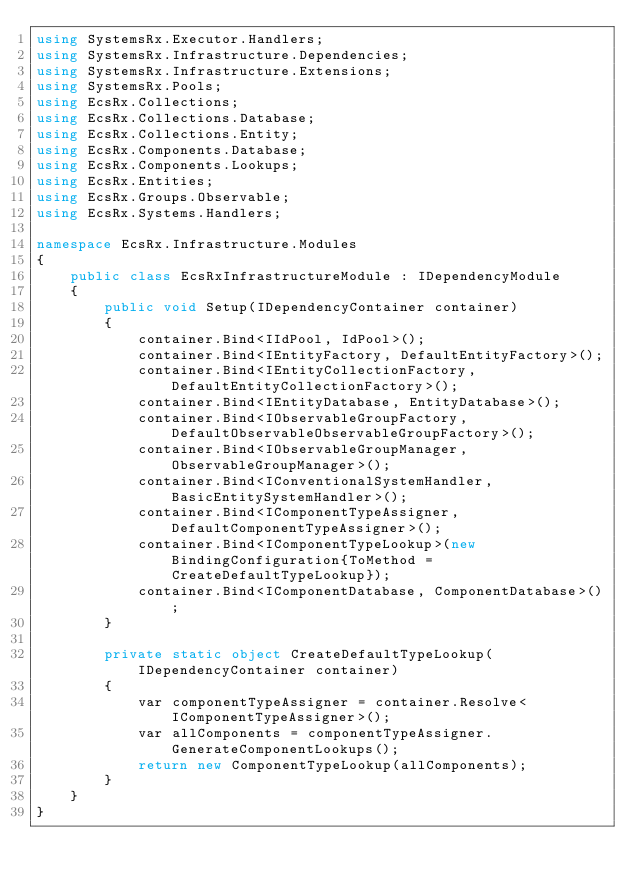Convert code to text. <code><loc_0><loc_0><loc_500><loc_500><_C#_>using SystemsRx.Executor.Handlers;
using SystemsRx.Infrastructure.Dependencies;
using SystemsRx.Infrastructure.Extensions;
using SystemsRx.Pools;
using EcsRx.Collections;
using EcsRx.Collections.Database;
using EcsRx.Collections.Entity;
using EcsRx.Components.Database;
using EcsRx.Components.Lookups;
using EcsRx.Entities;
using EcsRx.Groups.Observable;
using EcsRx.Systems.Handlers;

namespace EcsRx.Infrastructure.Modules
{
    public class EcsRxInfrastructureModule : IDependencyModule
    {
        public void Setup(IDependencyContainer container)
        {
            container.Bind<IIdPool, IdPool>();
            container.Bind<IEntityFactory, DefaultEntityFactory>();
            container.Bind<IEntityCollectionFactory, DefaultEntityCollectionFactory>();
            container.Bind<IEntityDatabase, EntityDatabase>();
            container.Bind<IObservableGroupFactory, DefaultObservableObservableGroupFactory>();
            container.Bind<IObservableGroupManager, ObservableGroupManager>();
            container.Bind<IConventionalSystemHandler, BasicEntitySystemHandler>();
            container.Bind<IComponentTypeAssigner, DefaultComponentTypeAssigner>();
            container.Bind<IComponentTypeLookup>(new BindingConfiguration{ToMethod = CreateDefaultTypeLookup});           
            container.Bind<IComponentDatabase, ComponentDatabase>();
        }

        private static object CreateDefaultTypeLookup(IDependencyContainer container)
        {
            var componentTypeAssigner = container.Resolve<IComponentTypeAssigner>();
            var allComponents = componentTypeAssigner.GenerateComponentLookups();
            return new ComponentTypeLookup(allComponents);
        }
    }
}</code> 